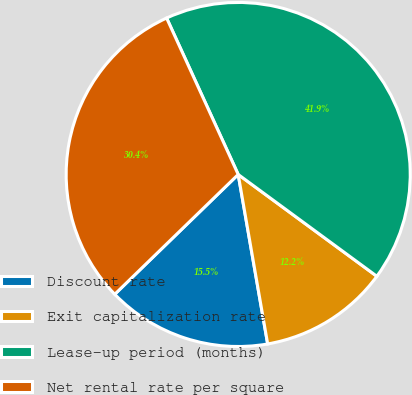Convert chart to OTSL. <chart><loc_0><loc_0><loc_500><loc_500><pie_chart><fcel>Discount rate<fcel>Exit capitalization rate<fcel>Lease-up period (months)<fcel>Net rental rate per square<nl><fcel>15.48%<fcel>12.18%<fcel>41.91%<fcel>30.43%<nl></chart> 